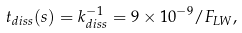Convert formula to latex. <formula><loc_0><loc_0><loc_500><loc_500>t _ { d i s s } ( s ) = k _ { d i s s } ^ { - 1 } = 9 \times 1 0 ^ { - 9 } / F _ { L W } ,</formula> 